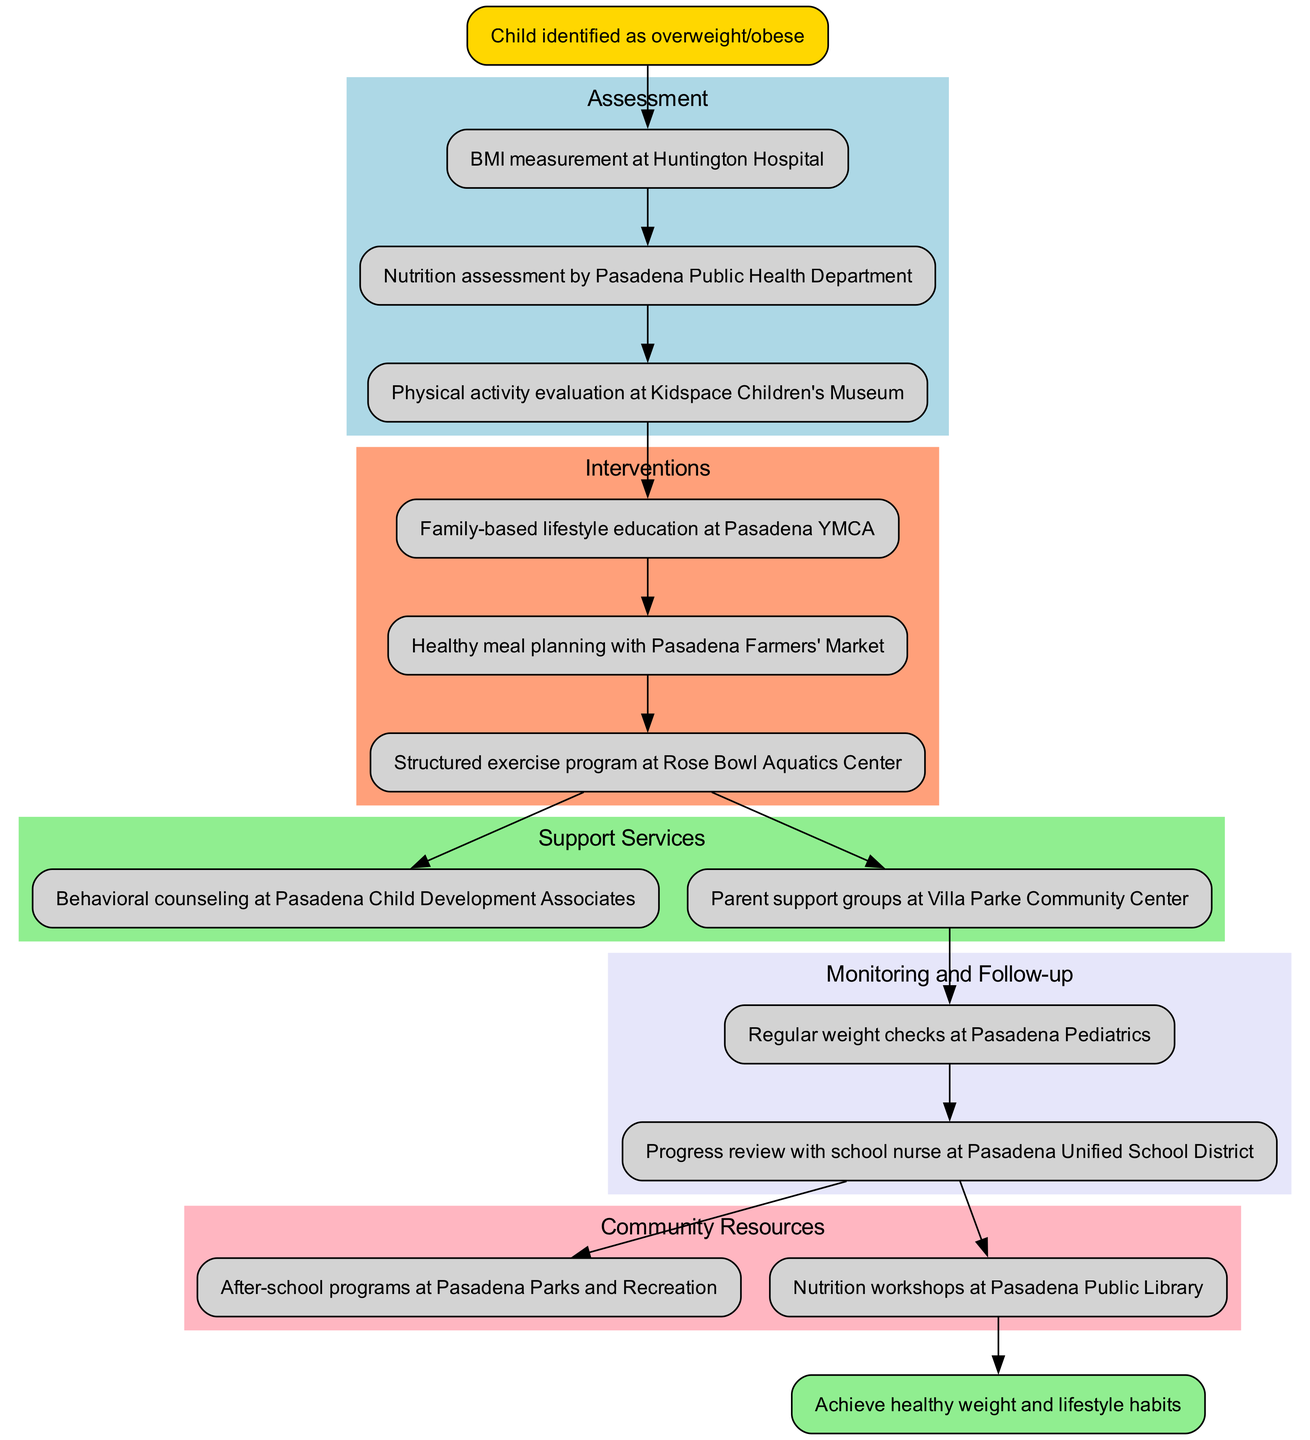What is the starting point of the clinical pathway? The starting point is identified as "Child identified as overweight/obese," as it directly indicates the initiation of the pathway.
Answer: Child identified as overweight/obese How many assessment steps are there in the pathway? By counting the nodes listed under 'Assessment,' we find three distinct assessment steps are mentioned in the diagram.
Answer: 3 What intervention follows the last assessment step? The last assessment step is "Physical activity evaluation at Kidspace Children's Museum," and the next direct intervention is "Family-based lifestyle education at Pasadena YMCA."
Answer: Family-based lifestyle education at Pasadena YMCA Which support service is provided after the interventions? The last intervention is "Structured exercise program at Rose Bowl Aquatics Center." The support service that comes next is "Behavioral counseling at Pasadena Child Development Associates."
Answer: Behavioral counseling at Pasadena Child Development Associates How many community resources are listed in the diagram? In the section for 'Community Resources,' there are two listed resources: "After-school programs at Pasadena Parks and Recreation" and "Nutrition workshops at Pasadena Public Library," totalling two resources.
Answer: 2 What is the endpoint of the clinical pathway? The final endpoint is clearly stated as "Achieve healthy weight and lifestyle habits," which signifies the goal of the whole pathway process.
Answer: Achieve healthy weight and lifestyle habits Which step is monitored last before reaching the endpoint? The last monitoring step before the endpoint is "Progress review with school nurse at Pasadena Unified School District," indicating the last evaluation before concluding the pathway.
Answer: Progress review with school nurse at Pasadena Unified School District Which node connects the interventions to the support services? The last intervention node, "Structured exercise program at Rose Bowl Aquatics Center," serves as the connecting node to the first support service, "Behavioral counseling at Pasadena Child Development Associates."
Answer: Structured exercise program at Rose Bowl Aquatics Center What is the color of the node representing assessment steps? The assessment steps are represented in a light blue color, which is consistent across all nodes in that section of the diagram.
Answer: light blue 